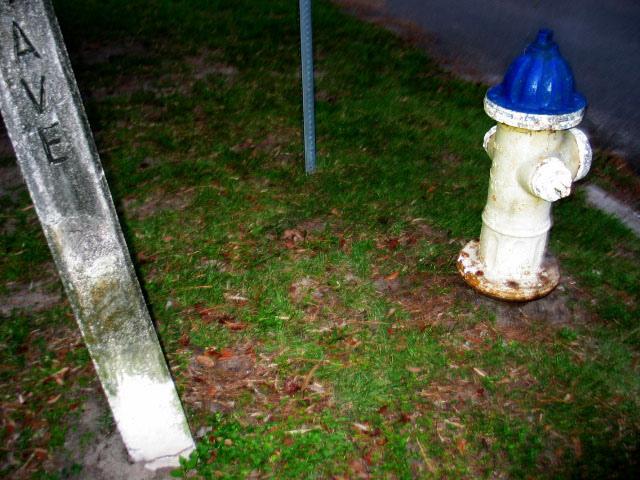What color is the top of the hydrant?
Short answer required. Blue. How old is this pump?
Short answer required. Old. Could the fire department get to this fire hydrant?
Keep it brief. Yes. What does the cement post say?
Be succinct. Ave. 